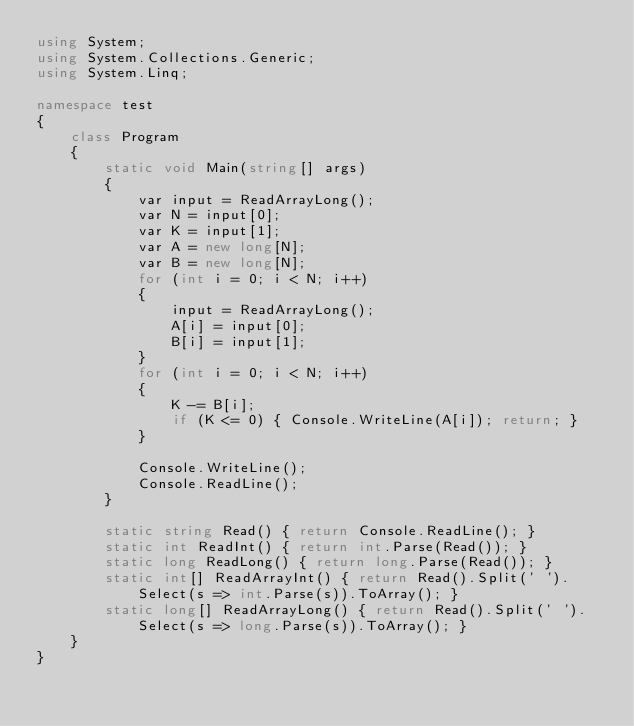<code> <loc_0><loc_0><loc_500><loc_500><_C#_>using System;
using System.Collections.Generic;
using System.Linq;

namespace test
{
    class Program
    {
        static void Main(string[] args)
        {
            var input = ReadArrayLong();
            var N = input[0];
            var K = input[1];
            var A = new long[N];
            var B = new long[N];
            for (int i = 0; i < N; i++)
            {
                input = ReadArrayLong();
                A[i] = input[0];
                B[i] = input[1];
            }
            for (int i = 0; i < N; i++)
            {
                K -= B[i];
                if (K <= 0) { Console.WriteLine(A[i]); return; }
            }

            Console.WriteLine();
            Console.ReadLine();
        }

        static string Read() { return Console.ReadLine(); }
        static int ReadInt() { return int.Parse(Read()); }
        static long ReadLong() { return long.Parse(Read()); }
        static int[] ReadArrayInt() { return Read().Split(' ').Select(s => int.Parse(s)).ToArray(); }
        static long[] ReadArrayLong() { return Read().Split(' ').Select(s => long.Parse(s)).ToArray(); }
    }
}</code> 